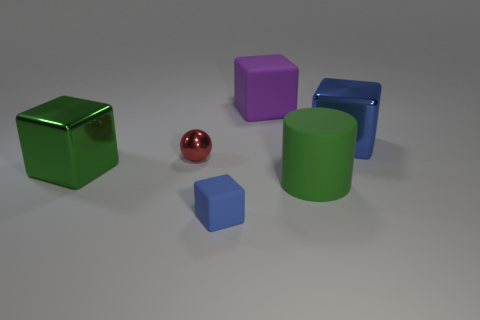Subtract all yellow cylinders. How many blue cubes are left? 2 Subtract all purple cubes. How many cubes are left? 3 Subtract 1 blocks. How many blocks are left? 3 Add 1 big brown shiny cylinders. How many objects exist? 7 Subtract all green cubes. How many cubes are left? 3 Subtract all red cubes. Subtract all gray cylinders. How many cubes are left? 4 Subtract all blocks. How many objects are left? 2 Add 1 metallic cubes. How many metallic cubes are left? 3 Add 3 tiny blue objects. How many tiny blue objects exist? 4 Subtract 1 green blocks. How many objects are left? 5 